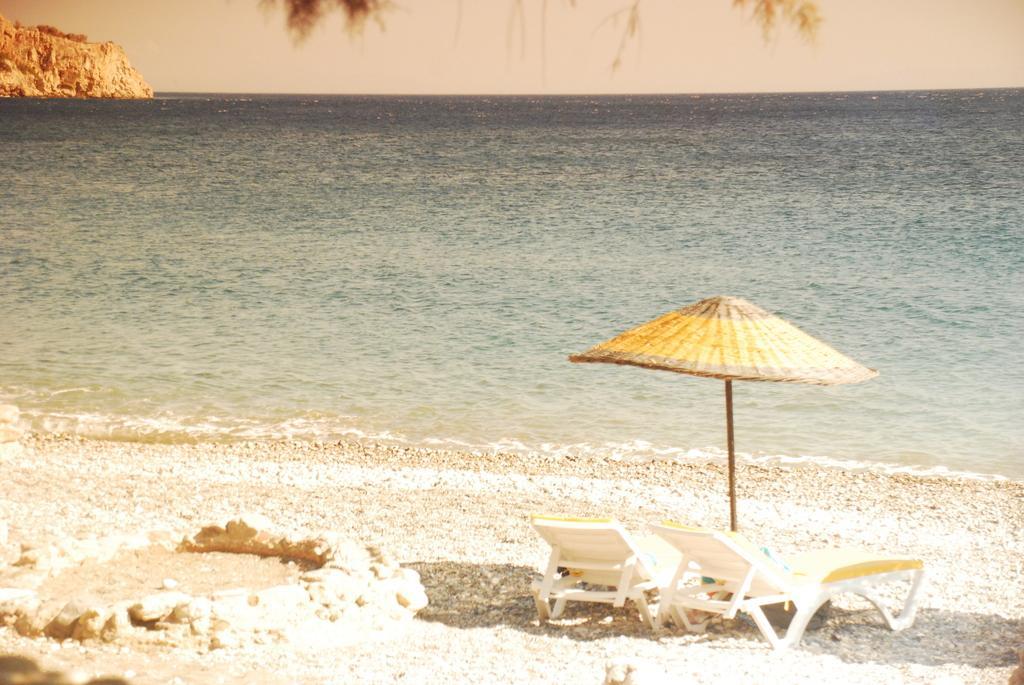In one or two sentences, can you explain what this image depicts? In this image there are beach chairs and an umbrella on the sea shore, water , and in the background there is sky. 